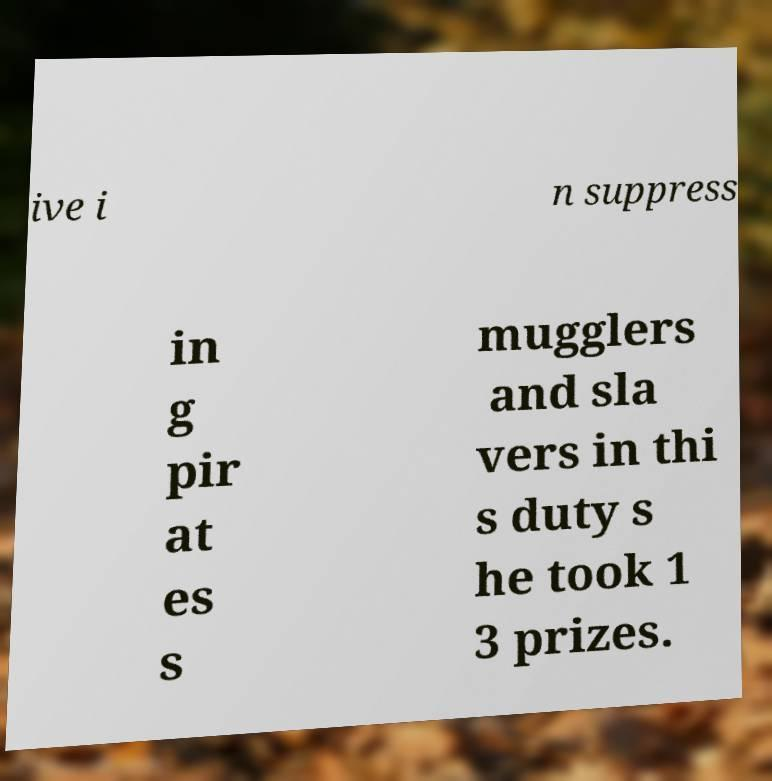Please identify and transcribe the text found in this image. ive i n suppress in g pir at es s mugglers and sla vers in thi s duty s he took 1 3 prizes. 